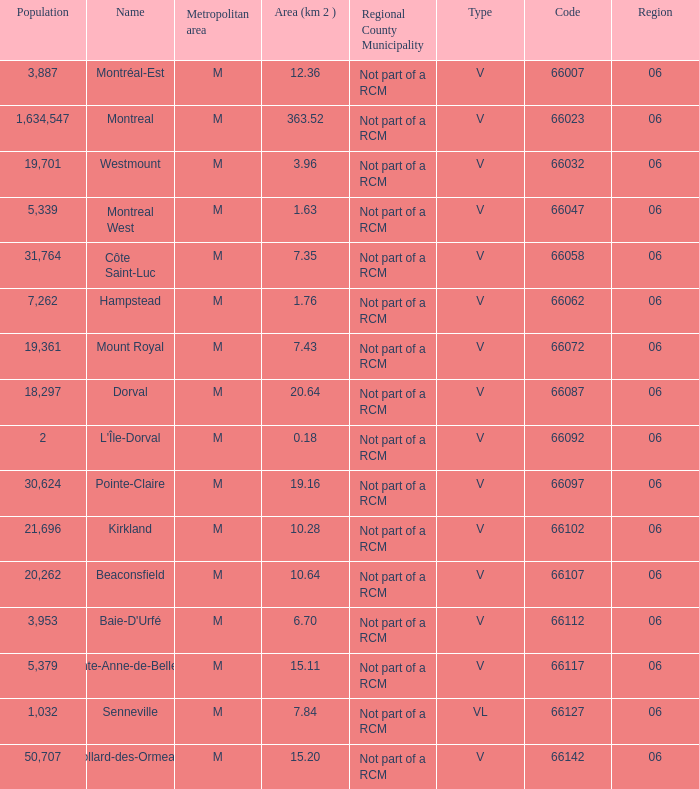What is the largest region with a Code smaller than 66112, and a Name of l'île-dorval? 6.0. 